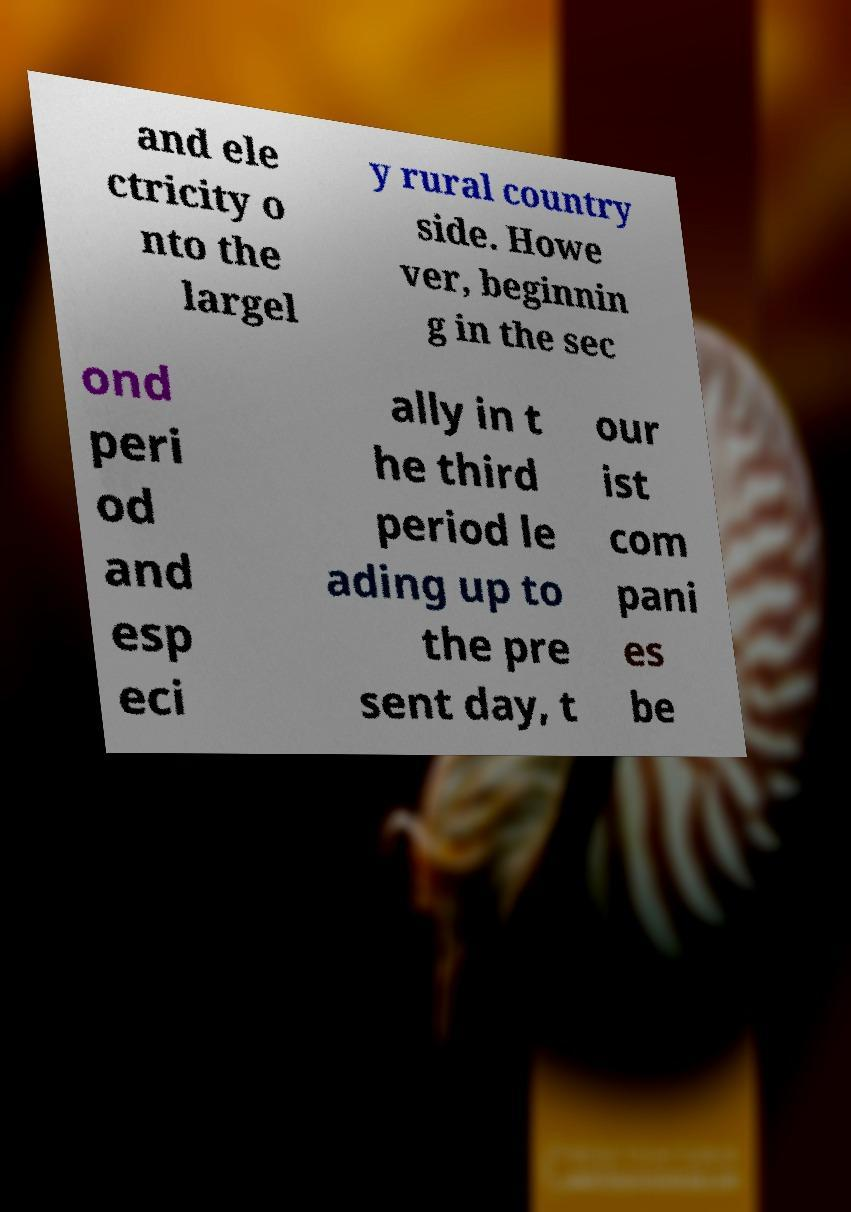Could you assist in decoding the text presented in this image and type it out clearly? and ele ctricity o nto the largel y rural country side. Howe ver, beginnin g in the sec ond peri od and esp eci ally in t he third period le ading up to the pre sent day, t our ist com pani es be 